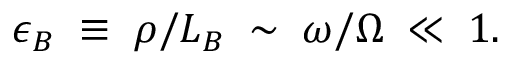<formula> <loc_0><loc_0><loc_500><loc_500>\epsilon _ { B } \, \equiv \, \rho / L _ { B } \, \sim \, \omega / \Omega \, \ll \, 1 .</formula> 